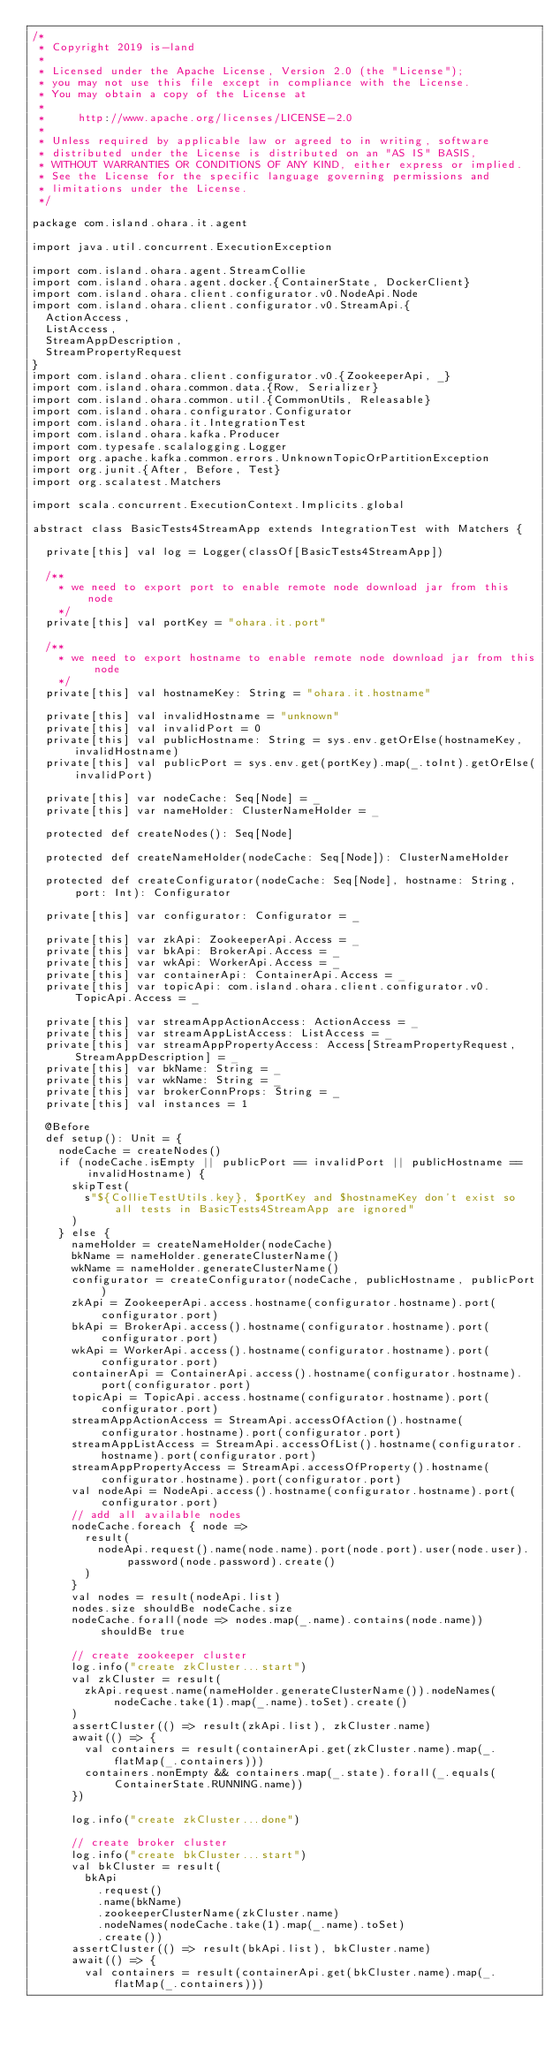<code> <loc_0><loc_0><loc_500><loc_500><_Scala_>/*
 * Copyright 2019 is-land
 *
 * Licensed under the Apache License, Version 2.0 (the "License");
 * you may not use this file except in compliance with the License.
 * You may obtain a copy of the License at
 *
 *     http://www.apache.org/licenses/LICENSE-2.0
 *
 * Unless required by applicable law or agreed to in writing, software
 * distributed under the License is distributed on an "AS IS" BASIS,
 * WITHOUT WARRANTIES OR CONDITIONS OF ANY KIND, either express or implied.
 * See the License for the specific language governing permissions and
 * limitations under the License.
 */

package com.island.ohara.it.agent

import java.util.concurrent.ExecutionException

import com.island.ohara.agent.StreamCollie
import com.island.ohara.agent.docker.{ContainerState, DockerClient}
import com.island.ohara.client.configurator.v0.NodeApi.Node
import com.island.ohara.client.configurator.v0.StreamApi.{
  ActionAccess,
  ListAccess,
  StreamAppDescription,
  StreamPropertyRequest
}
import com.island.ohara.client.configurator.v0.{ZookeeperApi, _}
import com.island.ohara.common.data.{Row, Serializer}
import com.island.ohara.common.util.{CommonUtils, Releasable}
import com.island.ohara.configurator.Configurator
import com.island.ohara.it.IntegrationTest
import com.island.ohara.kafka.Producer
import com.typesafe.scalalogging.Logger
import org.apache.kafka.common.errors.UnknownTopicOrPartitionException
import org.junit.{After, Before, Test}
import org.scalatest.Matchers

import scala.concurrent.ExecutionContext.Implicits.global

abstract class BasicTests4StreamApp extends IntegrationTest with Matchers {

  private[this] val log = Logger(classOf[BasicTests4StreamApp])

  /**
    * we need to export port to enable remote node download jar from this node
    */
  private[this] val portKey = "ohara.it.port"

  /**
    * we need to export hostname to enable remote node download jar from this node
    */
  private[this] val hostnameKey: String = "ohara.it.hostname"

  private[this] val invalidHostname = "unknown"
  private[this] val invalidPort = 0
  private[this] val publicHostname: String = sys.env.getOrElse(hostnameKey, invalidHostname)
  private[this] val publicPort = sys.env.get(portKey).map(_.toInt).getOrElse(invalidPort)

  private[this] var nodeCache: Seq[Node] = _
  private[this] var nameHolder: ClusterNameHolder = _

  protected def createNodes(): Seq[Node]

  protected def createNameHolder(nodeCache: Seq[Node]): ClusterNameHolder

  protected def createConfigurator(nodeCache: Seq[Node], hostname: String, port: Int): Configurator

  private[this] var configurator: Configurator = _

  private[this] var zkApi: ZookeeperApi.Access = _
  private[this] var bkApi: BrokerApi.Access = _
  private[this] var wkApi: WorkerApi.Access = _
  private[this] var containerApi: ContainerApi.Access = _
  private[this] var topicApi: com.island.ohara.client.configurator.v0.TopicApi.Access = _

  private[this] var streamAppActionAccess: ActionAccess = _
  private[this] var streamAppListAccess: ListAccess = _
  private[this] var streamAppPropertyAccess: Access[StreamPropertyRequest, StreamAppDescription] = _
  private[this] var bkName: String = _
  private[this] var wkName: String = _
  private[this] var brokerConnProps: String = _
  private[this] val instances = 1

  @Before
  def setup(): Unit = {
    nodeCache = createNodes()
    if (nodeCache.isEmpty || publicPort == invalidPort || publicHostname == invalidHostname) {
      skipTest(
        s"${CollieTestUtils.key}, $portKey and $hostnameKey don't exist so all tests in BasicTests4StreamApp are ignored"
      )
    } else {
      nameHolder = createNameHolder(nodeCache)
      bkName = nameHolder.generateClusterName()
      wkName = nameHolder.generateClusterName()
      configurator = createConfigurator(nodeCache, publicHostname, publicPort)
      zkApi = ZookeeperApi.access.hostname(configurator.hostname).port(configurator.port)
      bkApi = BrokerApi.access().hostname(configurator.hostname).port(configurator.port)
      wkApi = WorkerApi.access().hostname(configurator.hostname).port(configurator.port)
      containerApi = ContainerApi.access().hostname(configurator.hostname).port(configurator.port)
      topicApi = TopicApi.access.hostname(configurator.hostname).port(configurator.port)
      streamAppActionAccess = StreamApi.accessOfAction().hostname(configurator.hostname).port(configurator.port)
      streamAppListAccess = StreamApi.accessOfList().hostname(configurator.hostname).port(configurator.port)
      streamAppPropertyAccess = StreamApi.accessOfProperty().hostname(configurator.hostname).port(configurator.port)
      val nodeApi = NodeApi.access().hostname(configurator.hostname).port(configurator.port)
      // add all available nodes
      nodeCache.foreach { node =>
        result(
          nodeApi.request().name(node.name).port(node.port).user(node.user).password(node.password).create()
        )
      }
      val nodes = result(nodeApi.list)
      nodes.size shouldBe nodeCache.size
      nodeCache.forall(node => nodes.map(_.name).contains(node.name)) shouldBe true

      // create zookeeper cluster
      log.info("create zkCluster...start")
      val zkCluster = result(
        zkApi.request.name(nameHolder.generateClusterName()).nodeNames(nodeCache.take(1).map(_.name).toSet).create()
      )
      assertCluster(() => result(zkApi.list), zkCluster.name)
      await(() => {
        val containers = result(containerApi.get(zkCluster.name).map(_.flatMap(_.containers)))
        containers.nonEmpty && containers.map(_.state).forall(_.equals(ContainerState.RUNNING.name))
      })

      log.info("create zkCluster...done")

      // create broker cluster
      log.info("create bkCluster...start")
      val bkCluster = result(
        bkApi
          .request()
          .name(bkName)
          .zookeeperClusterName(zkCluster.name)
          .nodeNames(nodeCache.take(1).map(_.name).toSet)
          .create())
      assertCluster(() => result(bkApi.list), bkCluster.name)
      await(() => {
        val containers = result(containerApi.get(bkCluster.name).map(_.flatMap(_.containers)))</code> 